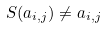<formula> <loc_0><loc_0><loc_500><loc_500>S ( a _ { i , j } ) \ne a _ { i , j }</formula> 